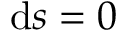Convert formula to latex. <formula><loc_0><loc_0><loc_500><loc_500>d s = 0</formula> 